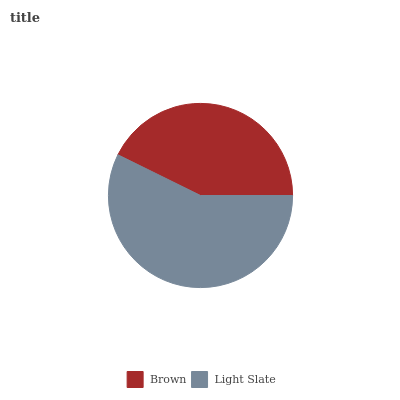Is Brown the minimum?
Answer yes or no. Yes. Is Light Slate the maximum?
Answer yes or no. Yes. Is Light Slate the minimum?
Answer yes or no. No. Is Light Slate greater than Brown?
Answer yes or no. Yes. Is Brown less than Light Slate?
Answer yes or no. Yes. Is Brown greater than Light Slate?
Answer yes or no. No. Is Light Slate less than Brown?
Answer yes or no. No. Is Light Slate the high median?
Answer yes or no. Yes. Is Brown the low median?
Answer yes or no. Yes. Is Brown the high median?
Answer yes or no. No. Is Light Slate the low median?
Answer yes or no. No. 